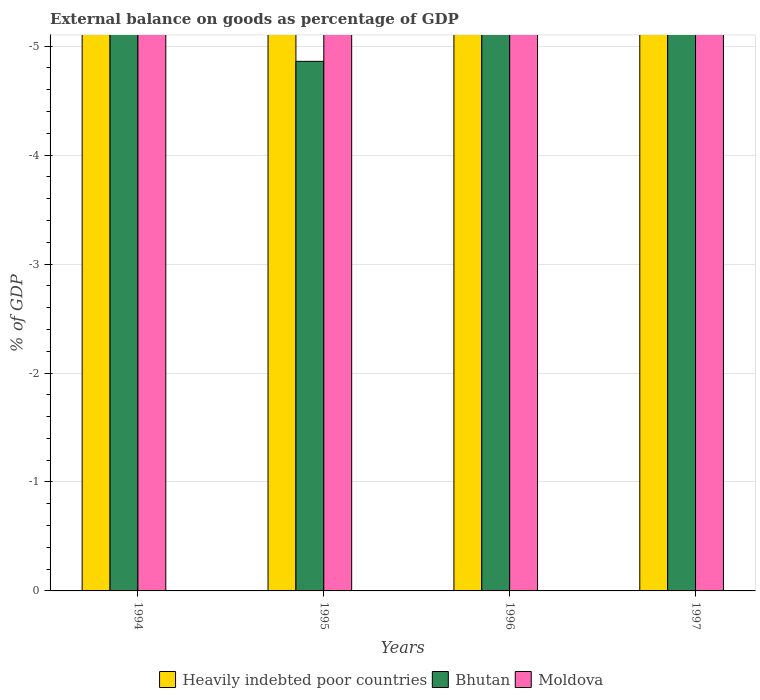Are the number of bars per tick equal to the number of legend labels?
Your response must be concise. No. How many bars are there on the 1st tick from the right?
Make the answer very short. 0. What is the difference between the external balance on goods as percentage of GDP in Heavily indebted poor countries in 1996 and the external balance on goods as percentage of GDP in Bhutan in 1994?
Provide a short and direct response. 0. What is the average external balance on goods as percentage of GDP in Bhutan per year?
Provide a short and direct response. 0. In how many years, is the external balance on goods as percentage of GDP in Heavily indebted poor countries greater than -1.6 %?
Provide a succinct answer. 0. How many years are there in the graph?
Give a very brief answer. 4. What is the difference between two consecutive major ticks on the Y-axis?
Offer a terse response. 1. Does the graph contain any zero values?
Give a very brief answer. Yes. Does the graph contain grids?
Your answer should be compact. Yes. Where does the legend appear in the graph?
Keep it short and to the point. Bottom center. What is the title of the graph?
Ensure brevity in your answer.  External balance on goods as percentage of GDP. What is the label or title of the Y-axis?
Make the answer very short. % of GDP. What is the % of GDP in Heavily indebted poor countries in 1994?
Provide a succinct answer. 0. What is the % of GDP of Bhutan in 1994?
Your answer should be very brief. 0. What is the % of GDP in Moldova in 1994?
Give a very brief answer. 0. What is the % of GDP in Bhutan in 1996?
Offer a very short reply. 0. What is the % of GDP in Moldova in 1996?
Make the answer very short. 0. What is the % of GDP in Heavily indebted poor countries in 1997?
Provide a succinct answer. 0. What is the % of GDP of Bhutan in 1997?
Make the answer very short. 0. What is the % of GDP in Moldova in 1997?
Provide a short and direct response. 0. What is the total % of GDP of Heavily indebted poor countries in the graph?
Offer a very short reply. 0. What is the total % of GDP of Bhutan in the graph?
Provide a short and direct response. 0. What is the total % of GDP of Moldova in the graph?
Ensure brevity in your answer.  0. What is the average % of GDP in Heavily indebted poor countries per year?
Provide a short and direct response. 0. 